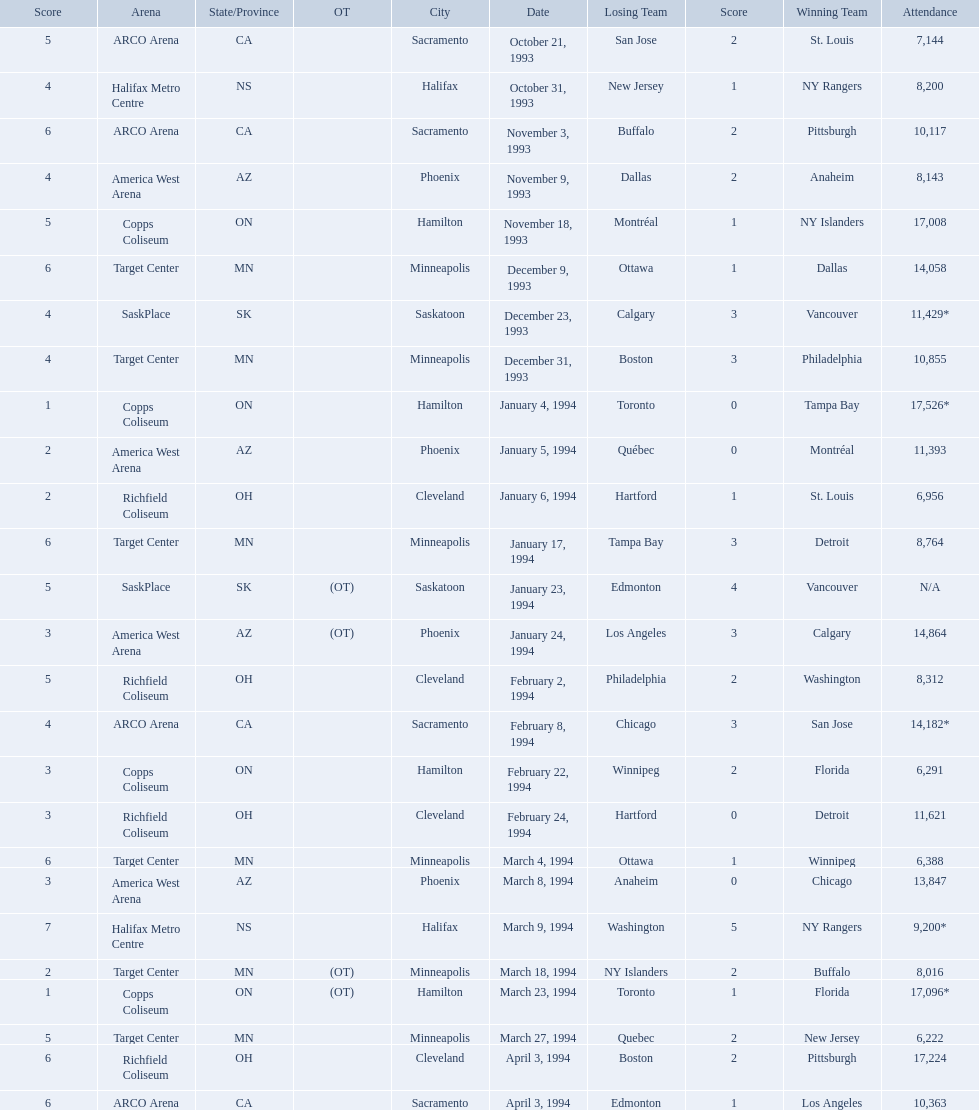On which dates were all the games? October 21, 1993, October 31, 1993, November 3, 1993, November 9, 1993, November 18, 1993, December 9, 1993, December 23, 1993, December 31, 1993, January 4, 1994, January 5, 1994, January 6, 1994, January 17, 1994, January 23, 1994, January 24, 1994, February 2, 1994, February 8, 1994, February 22, 1994, February 24, 1994, March 4, 1994, March 8, 1994, March 9, 1994, March 18, 1994, March 23, 1994, March 27, 1994, April 3, 1994, April 3, 1994. What were the attendances? 7,144, 8,200, 10,117, 8,143, 17,008, 14,058, 11,429*, 10,855, 17,526*, 11,393, 6,956, 8,764, N/A, 14,864, 8,312, 14,182*, 6,291, 11,621, 6,388, 13,847, 9,200*, 8,016, 17,096*, 6,222, 17,224, 10,363. And between december 23, 1993 and january 24, 1994, which game had the highest turnout? January 4, 1994. 